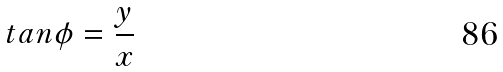<formula> <loc_0><loc_0><loc_500><loc_500>t a n \phi = \frac { y } { x }</formula> 